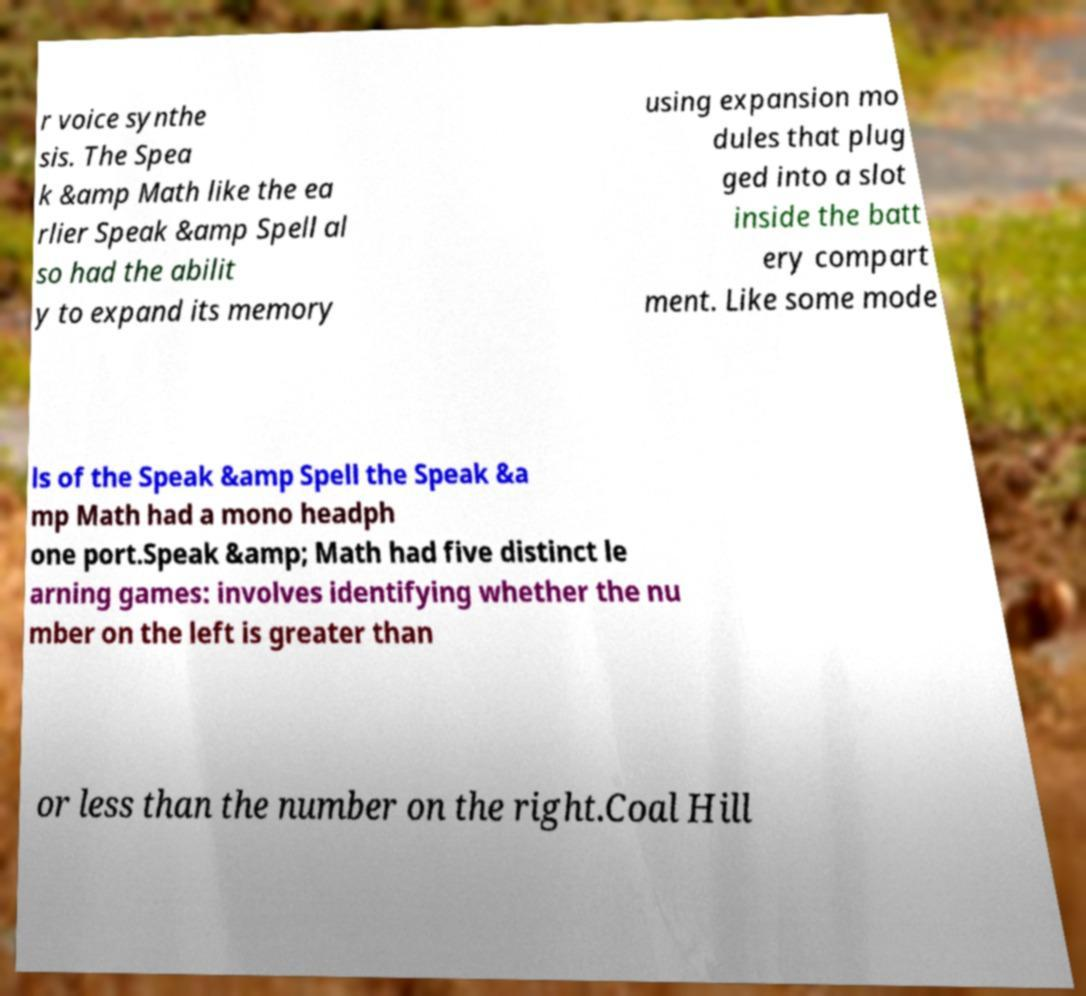What messages or text are displayed in this image? I need them in a readable, typed format. r voice synthe sis. The Spea k &amp Math like the ea rlier Speak &amp Spell al so had the abilit y to expand its memory using expansion mo dules that plug ged into a slot inside the batt ery compart ment. Like some mode ls of the Speak &amp Spell the Speak &a mp Math had a mono headph one port.Speak &amp; Math had five distinct le arning games: involves identifying whether the nu mber on the left is greater than or less than the number on the right.Coal Hill 